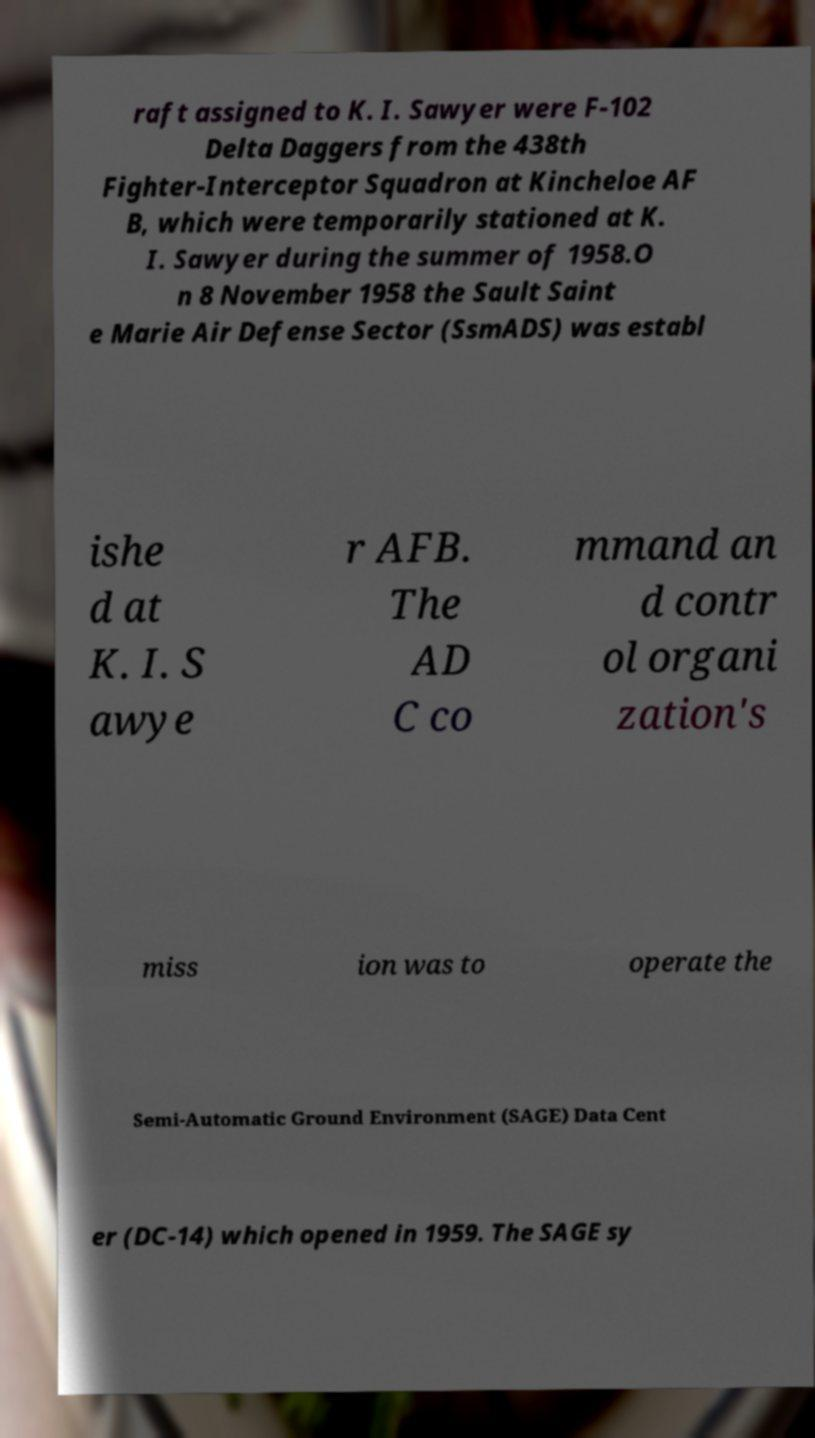Can you read and provide the text displayed in the image?This photo seems to have some interesting text. Can you extract and type it out for me? raft assigned to K. I. Sawyer were F-102 Delta Daggers from the 438th Fighter-Interceptor Squadron at Kincheloe AF B, which were temporarily stationed at K. I. Sawyer during the summer of 1958.O n 8 November 1958 the Sault Saint e Marie Air Defense Sector (SsmADS) was establ ishe d at K. I. S awye r AFB. The AD C co mmand an d contr ol organi zation's miss ion was to operate the Semi-Automatic Ground Environment (SAGE) Data Cent er (DC-14) which opened in 1959. The SAGE sy 